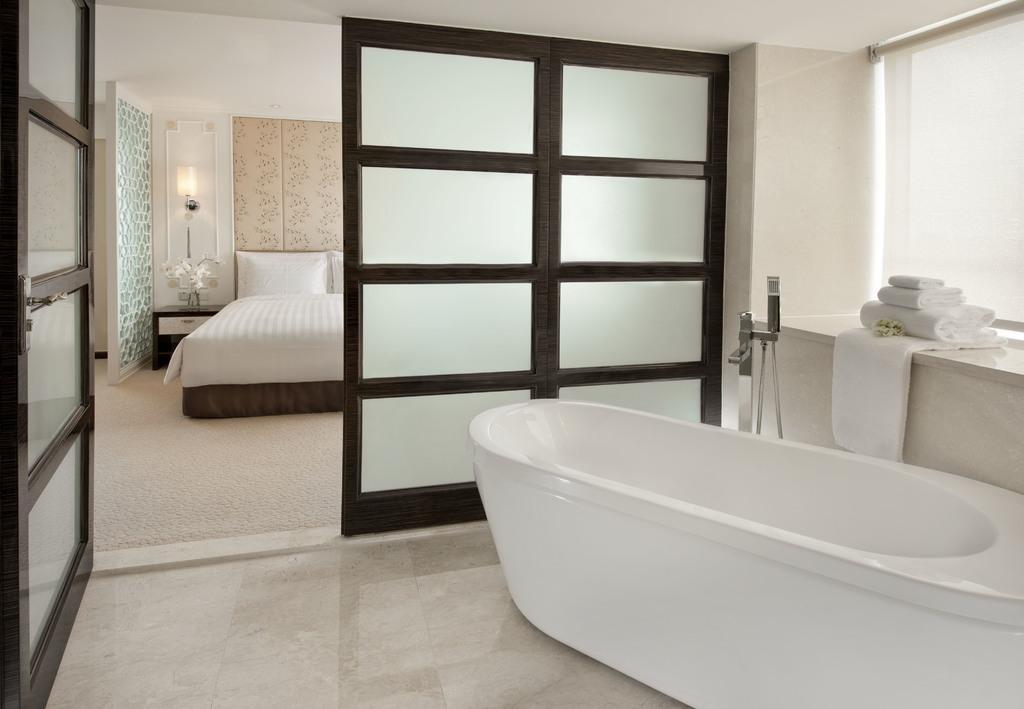Can you describe this image briefly? In this image, we can see a bathtub, some towels, a stand, doors and we can see pillows on the bed, a lamp and some decor on the stand and there is a wall. At the bottom, there is a floor. 